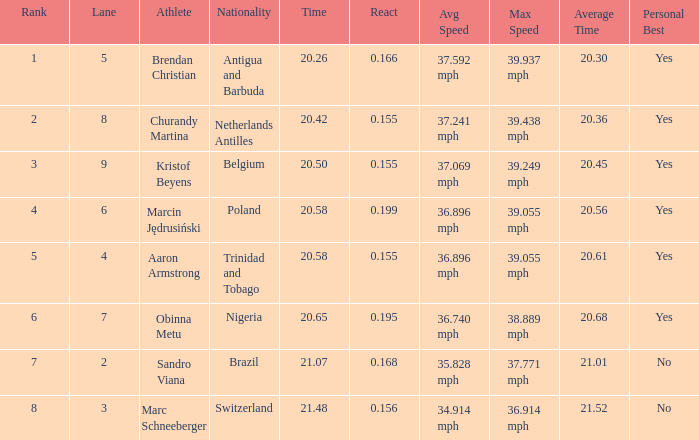Which Lane has a Time larger than 20.5, and a Nationality of trinidad and tobago? 4.0. 